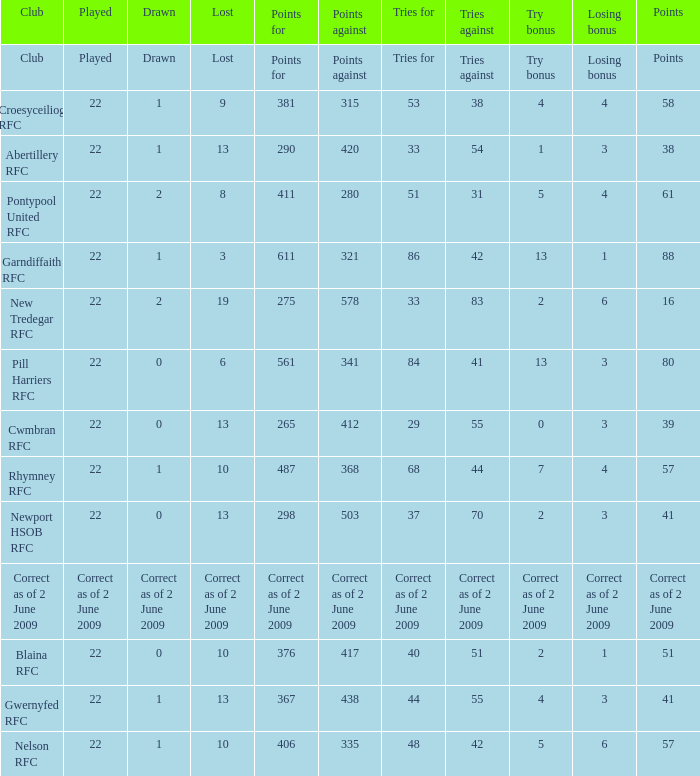How many tries did the club with a try bonus of correct as of 2 June 2009 have? Correct as of 2 June 2009. 